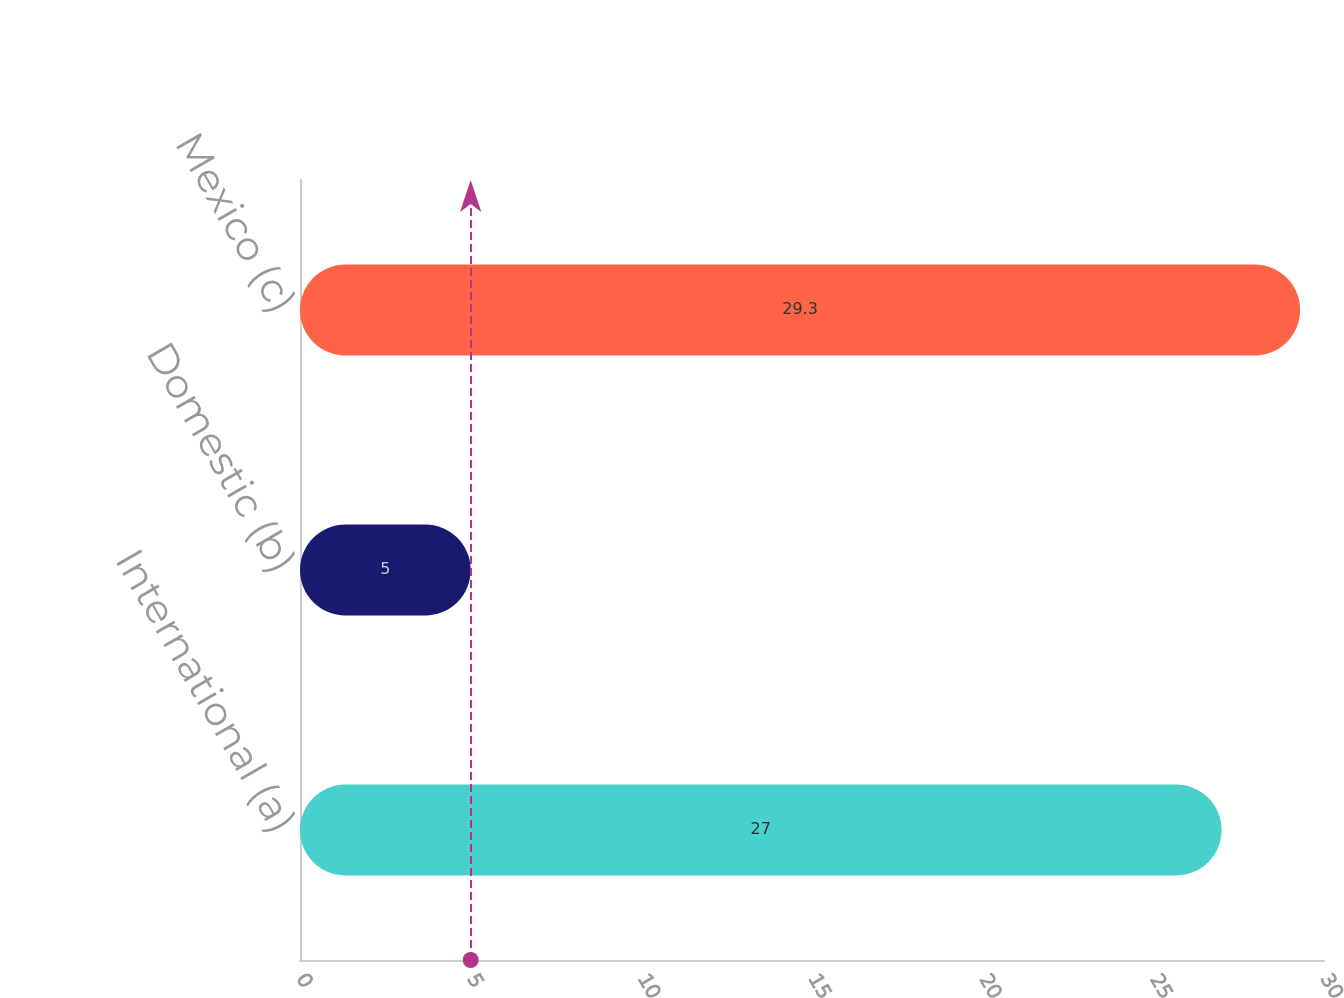Convert chart. <chart><loc_0><loc_0><loc_500><loc_500><bar_chart><fcel>International (a)<fcel>Domestic (b)<fcel>Mexico (c)<nl><fcel>27<fcel>5<fcel>29.3<nl></chart> 